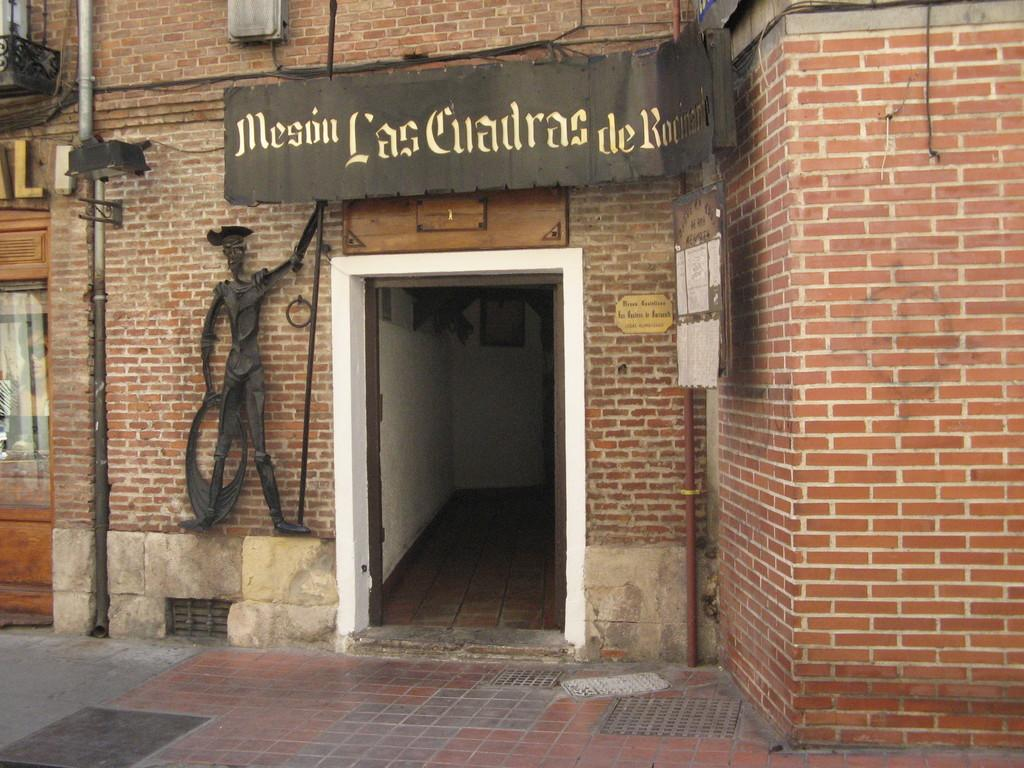What is the main structure in the picture? There is a building in the picture. What feature does the building have? The building has a door. Is there any signage on the building? Yes, there is a name board on the building. Who is holding the name board? A person is holding the name board. What type of gold jewelry can be seen on the person holding the name board? There is no gold jewelry visible on the person holding the name board in the image. What type of soda is being served at the building in the image? There is no information about soda or any food or beverage being served in the image. 